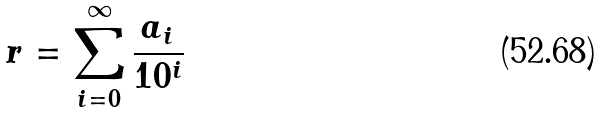Convert formula to latex. <formula><loc_0><loc_0><loc_500><loc_500>r = \sum _ { i = 0 } ^ { \infty } \frac { a _ { i } } { 1 0 ^ { i } }</formula> 